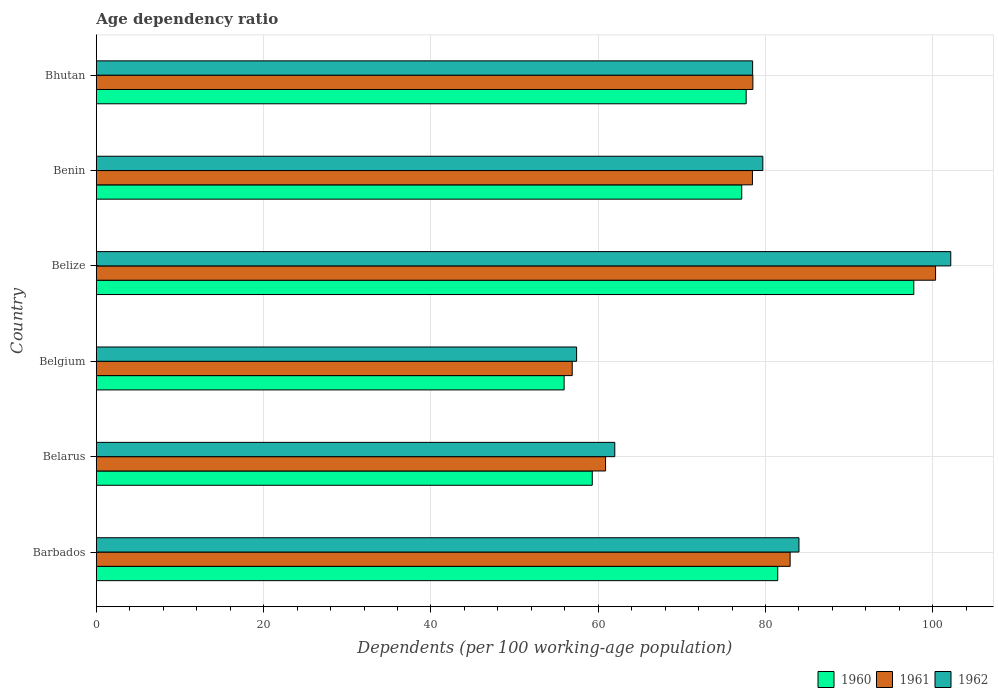How many groups of bars are there?
Your answer should be compact. 6. How many bars are there on the 5th tick from the bottom?
Give a very brief answer. 3. What is the label of the 2nd group of bars from the top?
Offer a very short reply. Benin. What is the age dependency ratio in in 1960 in Belgium?
Offer a terse response. 55.92. Across all countries, what is the maximum age dependency ratio in in 1960?
Give a very brief answer. 97.73. Across all countries, what is the minimum age dependency ratio in in 1962?
Provide a succinct answer. 57.42. In which country was the age dependency ratio in in 1961 maximum?
Your response must be concise. Belize. What is the total age dependency ratio in in 1961 in the graph?
Offer a very short reply. 457.97. What is the difference between the age dependency ratio in in 1960 in Barbados and that in Bhutan?
Ensure brevity in your answer.  3.77. What is the difference between the age dependency ratio in in 1962 in Benin and the age dependency ratio in in 1960 in Belgium?
Make the answer very short. 23.76. What is the average age dependency ratio in in 1961 per country?
Your answer should be compact. 76.33. What is the difference between the age dependency ratio in in 1962 and age dependency ratio in in 1960 in Barbados?
Provide a succinct answer. 2.54. What is the ratio of the age dependency ratio in in 1960 in Belarus to that in Belgium?
Offer a very short reply. 1.06. What is the difference between the highest and the second highest age dependency ratio in in 1960?
Offer a very short reply. 16.27. What is the difference between the highest and the lowest age dependency ratio in in 1962?
Your answer should be very brief. 44.73. Is the sum of the age dependency ratio in in 1962 in Barbados and Benin greater than the maximum age dependency ratio in in 1960 across all countries?
Make the answer very short. Yes. Is it the case that in every country, the sum of the age dependency ratio in in 1960 and age dependency ratio in in 1961 is greater than the age dependency ratio in in 1962?
Give a very brief answer. Yes. How many countries are there in the graph?
Keep it short and to the point. 6. What is the difference between two consecutive major ticks on the X-axis?
Your answer should be compact. 20. Are the values on the major ticks of X-axis written in scientific E-notation?
Give a very brief answer. No. What is the title of the graph?
Offer a very short reply. Age dependency ratio. What is the label or title of the X-axis?
Your answer should be very brief. Dependents (per 100 working-age population). What is the label or title of the Y-axis?
Give a very brief answer. Country. What is the Dependents (per 100 working-age population) of 1960 in Barbados?
Provide a succinct answer. 81.46. What is the Dependents (per 100 working-age population) of 1961 in Barbados?
Give a very brief answer. 82.94. What is the Dependents (per 100 working-age population) in 1962 in Barbados?
Offer a very short reply. 84. What is the Dependents (per 100 working-age population) in 1960 in Belarus?
Your answer should be compact. 59.29. What is the Dependents (per 100 working-age population) in 1961 in Belarus?
Provide a short and direct response. 60.88. What is the Dependents (per 100 working-age population) of 1962 in Belarus?
Make the answer very short. 61.98. What is the Dependents (per 100 working-age population) in 1960 in Belgium?
Your answer should be compact. 55.92. What is the Dependents (per 100 working-age population) in 1961 in Belgium?
Make the answer very short. 56.89. What is the Dependents (per 100 working-age population) in 1962 in Belgium?
Your response must be concise. 57.42. What is the Dependents (per 100 working-age population) in 1960 in Belize?
Ensure brevity in your answer.  97.73. What is the Dependents (per 100 working-age population) of 1961 in Belize?
Offer a terse response. 100.33. What is the Dependents (per 100 working-age population) in 1962 in Belize?
Keep it short and to the point. 102.15. What is the Dependents (per 100 working-age population) of 1960 in Benin?
Provide a short and direct response. 77.16. What is the Dependents (per 100 working-age population) of 1961 in Benin?
Offer a very short reply. 78.44. What is the Dependents (per 100 working-age population) in 1962 in Benin?
Offer a terse response. 79.68. What is the Dependents (per 100 working-age population) in 1960 in Bhutan?
Keep it short and to the point. 77.69. What is the Dependents (per 100 working-age population) in 1961 in Bhutan?
Offer a very short reply. 78.49. What is the Dependents (per 100 working-age population) in 1962 in Bhutan?
Your answer should be compact. 78.46. Across all countries, what is the maximum Dependents (per 100 working-age population) of 1960?
Offer a very short reply. 97.73. Across all countries, what is the maximum Dependents (per 100 working-age population) of 1961?
Ensure brevity in your answer.  100.33. Across all countries, what is the maximum Dependents (per 100 working-age population) in 1962?
Give a very brief answer. 102.15. Across all countries, what is the minimum Dependents (per 100 working-age population) in 1960?
Offer a terse response. 55.92. Across all countries, what is the minimum Dependents (per 100 working-age population) of 1961?
Offer a very short reply. 56.89. Across all countries, what is the minimum Dependents (per 100 working-age population) in 1962?
Offer a very short reply. 57.42. What is the total Dependents (per 100 working-age population) in 1960 in the graph?
Make the answer very short. 449.25. What is the total Dependents (per 100 working-age population) in 1961 in the graph?
Give a very brief answer. 457.97. What is the total Dependents (per 100 working-age population) of 1962 in the graph?
Your answer should be compact. 463.68. What is the difference between the Dependents (per 100 working-age population) in 1960 in Barbados and that in Belarus?
Offer a very short reply. 22.17. What is the difference between the Dependents (per 100 working-age population) in 1961 in Barbados and that in Belarus?
Keep it short and to the point. 22.06. What is the difference between the Dependents (per 100 working-age population) of 1962 in Barbados and that in Belarus?
Your answer should be compact. 22.02. What is the difference between the Dependents (per 100 working-age population) in 1960 in Barbados and that in Belgium?
Offer a terse response. 25.54. What is the difference between the Dependents (per 100 working-age population) of 1961 in Barbados and that in Belgium?
Offer a terse response. 26.05. What is the difference between the Dependents (per 100 working-age population) of 1962 in Barbados and that in Belgium?
Keep it short and to the point. 26.58. What is the difference between the Dependents (per 100 working-age population) of 1960 in Barbados and that in Belize?
Provide a succinct answer. -16.27. What is the difference between the Dependents (per 100 working-age population) in 1961 in Barbados and that in Belize?
Provide a succinct answer. -17.39. What is the difference between the Dependents (per 100 working-age population) in 1962 in Barbados and that in Belize?
Your answer should be compact. -18.15. What is the difference between the Dependents (per 100 working-age population) in 1960 in Barbados and that in Benin?
Offer a terse response. 4.3. What is the difference between the Dependents (per 100 working-age population) of 1961 in Barbados and that in Benin?
Provide a succinct answer. 4.51. What is the difference between the Dependents (per 100 working-age population) of 1962 in Barbados and that in Benin?
Your answer should be very brief. 4.32. What is the difference between the Dependents (per 100 working-age population) of 1960 in Barbados and that in Bhutan?
Provide a short and direct response. 3.77. What is the difference between the Dependents (per 100 working-age population) in 1961 in Barbados and that in Bhutan?
Provide a short and direct response. 4.45. What is the difference between the Dependents (per 100 working-age population) of 1962 in Barbados and that in Bhutan?
Keep it short and to the point. 5.54. What is the difference between the Dependents (per 100 working-age population) in 1960 in Belarus and that in Belgium?
Your answer should be very brief. 3.36. What is the difference between the Dependents (per 100 working-age population) in 1961 in Belarus and that in Belgium?
Keep it short and to the point. 3.99. What is the difference between the Dependents (per 100 working-age population) of 1962 in Belarus and that in Belgium?
Offer a very short reply. 4.56. What is the difference between the Dependents (per 100 working-age population) in 1960 in Belarus and that in Belize?
Offer a terse response. -38.44. What is the difference between the Dependents (per 100 working-age population) of 1961 in Belarus and that in Belize?
Your answer should be very brief. -39.45. What is the difference between the Dependents (per 100 working-age population) in 1962 in Belarus and that in Belize?
Offer a very short reply. -40.17. What is the difference between the Dependents (per 100 working-age population) of 1960 in Belarus and that in Benin?
Your answer should be compact. -17.87. What is the difference between the Dependents (per 100 working-age population) in 1961 in Belarus and that in Benin?
Give a very brief answer. -17.56. What is the difference between the Dependents (per 100 working-age population) in 1962 in Belarus and that in Benin?
Ensure brevity in your answer.  -17.7. What is the difference between the Dependents (per 100 working-age population) of 1960 in Belarus and that in Bhutan?
Make the answer very short. -18.4. What is the difference between the Dependents (per 100 working-age population) in 1961 in Belarus and that in Bhutan?
Provide a short and direct response. -17.61. What is the difference between the Dependents (per 100 working-age population) of 1962 in Belarus and that in Bhutan?
Provide a succinct answer. -16.48. What is the difference between the Dependents (per 100 working-age population) of 1960 in Belgium and that in Belize?
Your answer should be very brief. -41.8. What is the difference between the Dependents (per 100 working-age population) of 1961 in Belgium and that in Belize?
Ensure brevity in your answer.  -43.44. What is the difference between the Dependents (per 100 working-age population) of 1962 in Belgium and that in Belize?
Provide a short and direct response. -44.73. What is the difference between the Dependents (per 100 working-age population) in 1960 in Belgium and that in Benin?
Keep it short and to the point. -21.23. What is the difference between the Dependents (per 100 working-age population) in 1961 in Belgium and that in Benin?
Your answer should be very brief. -21.55. What is the difference between the Dependents (per 100 working-age population) of 1962 in Belgium and that in Benin?
Ensure brevity in your answer.  -22.26. What is the difference between the Dependents (per 100 working-age population) in 1960 in Belgium and that in Bhutan?
Your answer should be compact. -21.76. What is the difference between the Dependents (per 100 working-age population) in 1961 in Belgium and that in Bhutan?
Your response must be concise. -21.6. What is the difference between the Dependents (per 100 working-age population) of 1962 in Belgium and that in Bhutan?
Your answer should be compact. -21.04. What is the difference between the Dependents (per 100 working-age population) of 1960 in Belize and that in Benin?
Ensure brevity in your answer.  20.57. What is the difference between the Dependents (per 100 working-age population) of 1961 in Belize and that in Benin?
Provide a short and direct response. 21.89. What is the difference between the Dependents (per 100 working-age population) in 1962 in Belize and that in Benin?
Offer a very short reply. 22.47. What is the difference between the Dependents (per 100 working-age population) in 1960 in Belize and that in Bhutan?
Your answer should be compact. 20.04. What is the difference between the Dependents (per 100 working-age population) of 1961 in Belize and that in Bhutan?
Give a very brief answer. 21.84. What is the difference between the Dependents (per 100 working-age population) in 1962 in Belize and that in Bhutan?
Your answer should be compact. 23.69. What is the difference between the Dependents (per 100 working-age population) in 1960 in Benin and that in Bhutan?
Provide a short and direct response. -0.53. What is the difference between the Dependents (per 100 working-age population) of 1961 in Benin and that in Bhutan?
Provide a short and direct response. -0.05. What is the difference between the Dependents (per 100 working-age population) in 1962 in Benin and that in Bhutan?
Keep it short and to the point. 1.22. What is the difference between the Dependents (per 100 working-age population) in 1960 in Barbados and the Dependents (per 100 working-age population) in 1961 in Belarus?
Provide a short and direct response. 20.58. What is the difference between the Dependents (per 100 working-age population) in 1960 in Barbados and the Dependents (per 100 working-age population) in 1962 in Belarus?
Keep it short and to the point. 19.48. What is the difference between the Dependents (per 100 working-age population) in 1961 in Barbados and the Dependents (per 100 working-age population) in 1962 in Belarus?
Your answer should be very brief. 20.96. What is the difference between the Dependents (per 100 working-age population) in 1960 in Barbados and the Dependents (per 100 working-age population) in 1961 in Belgium?
Your answer should be compact. 24.57. What is the difference between the Dependents (per 100 working-age population) of 1960 in Barbados and the Dependents (per 100 working-age population) of 1962 in Belgium?
Provide a short and direct response. 24.04. What is the difference between the Dependents (per 100 working-age population) of 1961 in Barbados and the Dependents (per 100 working-age population) of 1962 in Belgium?
Your answer should be compact. 25.53. What is the difference between the Dependents (per 100 working-age population) in 1960 in Barbados and the Dependents (per 100 working-age population) in 1961 in Belize?
Your answer should be compact. -18.87. What is the difference between the Dependents (per 100 working-age population) of 1960 in Barbados and the Dependents (per 100 working-age population) of 1962 in Belize?
Offer a terse response. -20.69. What is the difference between the Dependents (per 100 working-age population) in 1961 in Barbados and the Dependents (per 100 working-age population) in 1962 in Belize?
Offer a terse response. -19.2. What is the difference between the Dependents (per 100 working-age population) in 1960 in Barbados and the Dependents (per 100 working-age population) in 1961 in Benin?
Ensure brevity in your answer.  3.02. What is the difference between the Dependents (per 100 working-age population) of 1960 in Barbados and the Dependents (per 100 working-age population) of 1962 in Benin?
Provide a succinct answer. 1.78. What is the difference between the Dependents (per 100 working-age population) of 1961 in Barbados and the Dependents (per 100 working-age population) of 1962 in Benin?
Provide a short and direct response. 3.26. What is the difference between the Dependents (per 100 working-age population) in 1960 in Barbados and the Dependents (per 100 working-age population) in 1961 in Bhutan?
Make the answer very short. 2.97. What is the difference between the Dependents (per 100 working-age population) in 1960 in Barbados and the Dependents (per 100 working-age population) in 1962 in Bhutan?
Give a very brief answer. 3. What is the difference between the Dependents (per 100 working-age population) of 1961 in Barbados and the Dependents (per 100 working-age population) of 1962 in Bhutan?
Your answer should be very brief. 4.48. What is the difference between the Dependents (per 100 working-age population) of 1960 in Belarus and the Dependents (per 100 working-age population) of 1961 in Belgium?
Your answer should be compact. 2.4. What is the difference between the Dependents (per 100 working-age population) of 1960 in Belarus and the Dependents (per 100 working-age population) of 1962 in Belgium?
Ensure brevity in your answer.  1.87. What is the difference between the Dependents (per 100 working-age population) of 1961 in Belarus and the Dependents (per 100 working-age population) of 1962 in Belgium?
Your answer should be very brief. 3.46. What is the difference between the Dependents (per 100 working-age population) of 1960 in Belarus and the Dependents (per 100 working-age population) of 1961 in Belize?
Give a very brief answer. -41.04. What is the difference between the Dependents (per 100 working-age population) in 1960 in Belarus and the Dependents (per 100 working-age population) in 1962 in Belize?
Provide a succinct answer. -42.86. What is the difference between the Dependents (per 100 working-age population) of 1961 in Belarus and the Dependents (per 100 working-age population) of 1962 in Belize?
Your answer should be compact. -41.27. What is the difference between the Dependents (per 100 working-age population) in 1960 in Belarus and the Dependents (per 100 working-age population) in 1961 in Benin?
Give a very brief answer. -19.15. What is the difference between the Dependents (per 100 working-age population) of 1960 in Belarus and the Dependents (per 100 working-age population) of 1962 in Benin?
Ensure brevity in your answer.  -20.39. What is the difference between the Dependents (per 100 working-age population) in 1961 in Belarus and the Dependents (per 100 working-age population) in 1962 in Benin?
Keep it short and to the point. -18.8. What is the difference between the Dependents (per 100 working-age population) in 1960 in Belarus and the Dependents (per 100 working-age population) in 1961 in Bhutan?
Your answer should be compact. -19.2. What is the difference between the Dependents (per 100 working-age population) of 1960 in Belarus and the Dependents (per 100 working-age population) of 1962 in Bhutan?
Keep it short and to the point. -19.17. What is the difference between the Dependents (per 100 working-age population) of 1961 in Belarus and the Dependents (per 100 working-age population) of 1962 in Bhutan?
Provide a succinct answer. -17.58. What is the difference between the Dependents (per 100 working-age population) of 1960 in Belgium and the Dependents (per 100 working-age population) of 1961 in Belize?
Offer a very short reply. -44.41. What is the difference between the Dependents (per 100 working-age population) in 1960 in Belgium and the Dependents (per 100 working-age population) in 1962 in Belize?
Your answer should be compact. -46.22. What is the difference between the Dependents (per 100 working-age population) of 1961 in Belgium and the Dependents (per 100 working-age population) of 1962 in Belize?
Your answer should be very brief. -45.26. What is the difference between the Dependents (per 100 working-age population) of 1960 in Belgium and the Dependents (per 100 working-age population) of 1961 in Benin?
Offer a terse response. -22.51. What is the difference between the Dependents (per 100 working-age population) in 1960 in Belgium and the Dependents (per 100 working-age population) in 1962 in Benin?
Ensure brevity in your answer.  -23.76. What is the difference between the Dependents (per 100 working-age population) of 1961 in Belgium and the Dependents (per 100 working-age population) of 1962 in Benin?
Your response must be concise. -22.79. What is the difference between the Dependents (per 100 working-age population) in 1960 in Belgium and the Dependents (per 100 working-age population) in 1961 in Bhutan?
Provide a short and direct response. -22.56. What is the difference between the Dependents (per 100 working-age population) in 1960 in Belgium and the Dependents (per 100 working-age population) in 1962 in Bhutan?
Your response must be concise. -22.54. What is the difference between the Dependents (per 100 working-age population) of 1961 in Belgium and the Dependents (per 100 working-age population) of 1962 in Bhutan?
Offer a very short reply. -21.57. What is the difference between the Dependents (per 100 working-age population) of 1960 in Belize and the Dependents (per 100 working-age population) of 1961 in Benin?
Offer a terse response. 19.29. What is the difference between the Dependents (per 100 working-age population) of 1960 in Belize and the Dependents (per 100 working-age population) of 1962 in Benin?
Give a very brief answer. 18.05. What is the difference between the Dependents (per 100 working-age population) in 1961 in Belize and the Dependents (per 100 working-age population) in 1962 in Benin?
Make the answer very short. 20.65. What is the difference between the Dependents (per 100 working-age population) in 1960 in Belize and the Dependents (per 100 working-age population) in 1961 in Bhutan?
Your response must be concise. 19.24. What is the difference between the Dependents (per 100 working-age population) of 1960 in Belize and the Dependents (per 100 working-age population) of 1962 in Bhutan?
Provide a succinct answer. 19.27. What is the difference between the Dependents (per 100 working-age population) of 1961 in Belize and the Dependents (per 100 working-age population) of 1962 in Bhutan?
Your answer should be very brief. 21.87. What is the difference between the Dependents (per 100 working-age population) in 1960 in Benin and the Dependents (per 100 working-age population) in 1961 in Bhutan?
Give a very brief answer. -1.33. What is the difference between the Dependents (per 100 working-age population) of 1960 in Benin and the Dependents (per 100 working-age population) of 1962 in Bhutan?
Ensure brevity in your answer.  -1.3. What is the difference between the Dependents (per 100 working-age population) of 1961 in Benin and the Dependents (per 100 working-age population) of 1962 in Bhutan?
Ensure brevity in your answer.  -0.02. What is the average Dependents (per 100 working-age population) in 1960 per country?
Give a very brief answer. 74.87. What is the average Dependents (per 100 working-age population) of 1961 per country?
Give a very brief answer. 76.33. What is the average Dependents (per 100 working-age population) of 1962 per country?
Keep it short and to the point. 77.28. What is the difference between the Dependents (per 100 working-age population) in 1960 and Dependents (per 100 working-age population) in 1961 in Barbados?
Provide a short and direct response. -1.48. What is the difference between the Dependents (per 100 working-age population) of 1960 and Dependents (per 100 working-age population) of 1962 in Barbados?
Your response must be concise. -2.54. What is the difference between the Dependents (per 100 working-age population) of 1961 and Dependents (per 100 working-age population) of 1962 in Barbados?
Keep it short and to the point. -1.06. What is the difference between the Dependents (per 100 working-age population) of 1960 and Dependents (per 100 working-age population) of 1961 in Belarus?
Offer a very short reply. -1.59. What is the difference between the Dependents (per 100 working-age population) in 1960 and Dependents (per 100 working-age population) in 1962 in Belarus?
Ensure brevity in your answer.  -2.69. What is the difference between the Dependents (per 100 working-age population) in 1961 and Dependents (per 100 working-age population) in 1962 in Belarus?
Give a very brief answer. -1.1. What is the difference between the Dependents (per 100 working-age population) in 1960 and Dependents (per 100 working-age population) in 1961 in Belgium?
Your answer should be very brief. -0.97. What is the difference between the Dependents (per 100 working-age population) in 1960 and Dependents (per 100 working-age population) in 1962 in Belgium?
Provide a succinct answer. -1.49. What is the difference between the Dependents (per 100 working-age population) in 1961 and Dependents (per 100 working-age population) in 1962 in Belgium?
Make the answer very short. -0.53. What is the difference between the Dependents (per 100 working-age population) in 1960 and Dependents (per 100 working-age population) in 1961 in Belize?
Ensure brevity in your answer.  -2.6. What is the difference between the Dependents (per 100 working-age population) in 1960 and Dependents (per 100 working-age population) in 1962 in Belize?
Your answer should be very brief. -4.42. What is the difference between the Dependents (per 100 working-age population) of 1961 and Dependents (per 100 working-age population) of 1962 in Belize?
Provide a short and direct response. -1.82. What is the difference between the Dependents (per 100 working-age population) of 1960 and Dependents (per 100 working-age population) of 1961 in Benin?
Your response must be concise. -1.28. What is the difference between the Dependents (per 100 working-age population) of 1960 and Dependents (per 100 working-age population) of 1962 in Benin?
Offer a very short reply. -2.52. What is the difference between the Dependents (per 100 working-age population) in 1961 and Dependents (per 100 working-age population) in 1962 in Benin?
Ensure brevity in your answer.  -1.24. What is the difference between the Dependents (per 100 working-age population) in 1960 and Dependents (per 100 working-age population) in 1961 in Bhutan?
Your response must be concise. -0.8. What is the difference between the Dependents (per 100 working-age population) in 1960 and Dependents (per 100 working-age population) in 1962 in Bhutan?
Offer a terse response. -0.77. What is the difference between the Dependents (per 100 working-age population) in 1961 and Dependents (per 100 working-age population) in 1962 in Bhutan?
Your response must be concise. 0.03. What is the ratio of the Dependents (per 100 working-age population) of 1960 in Barbados to that in Belarus?
Provide a succinct answer. 1.37. What is the ratio of the Dependents (per 100 working-age population) of 1961 in Barbados to that in Belarus?
Provide a short and direct response. 1.36. What is the ratio of the Dependents (per 100 working-age population) of 1962 in Barbados to that in Belarus?
Ensure brevity in your answer.  1.36. What is the ratio of the Dependents (per 100 working-age population) of 1960 in Barbados to that in Belgium?
Your answer should be very brief. 1.46. What is the ratio of the Dependents (per 100 working-age population) in 1961 in Barbados to that in Belgium?
Provide a short and direct response. 1.46. What is the ratio of the Dependents (per 100 working-age population) of 1962 in Barbados to that in Belgium?
Offer a very short reply. 1.46. What is the ratio of the Dependents (per 100 working-age population) of 1960 in Barbados to that in Belize?
Make the answer very short. 0.83. What is the ratio of the Dependents (per 100 working-age population) in 1961 in Barbados to that in Belize?
Your answer should be very brief. 0.83. What is the ratio of the Dependents (per 100 working-age population) of 1962 in Barbados to that in Belize?
Offer a terse response. 0.82. What is the ratio of the Dependents (per 100 working-age population) of 1960 in Barbados to that in Benin?
Your response must be concise. 1.06. What is the ratio of the Dependents (per 100 working-age population) of 1961 in Barbados to that in Benin?
Keep it short and to the point. 1.06. What is the ratio of the Dependents (per 100 working-age population) in 1962 in Barbados to that in Benin?
Give a very brief answer. 1.05. What is the ratio of the Dependents (per 100 working-age population) of 1960 in Barbados to that in Bhutan?
Provide a succinct answer. 1.05. What is the ratio of the Dependents (per 100 working-age population) in 1961 in Barbados to that in Bhutan?
Give a very brief answer. 1.06. What is the ratio of the Dependents (per 100 working-age population) in 1962 in Barbados to that in Bhutan?
Your response must be concise. 1.07. What is the ratio of the Dependents (per 100 working-age population) of 1960 in Belarus to that in Belgium?
Offer a very short reply. 1.06. What is the ratio of the Dependents (per 100 working-age population) of 1961 in Belarus to that in Belgium?
Make the answer very short. 1.07. What is the ratio of the Dependents (per 100 working-age population) in 1962 in Belarus to that in Belgium?
Your response must be concise. 1.08. What is the ratio of the Dependents (per 100 working-age population) of 1960 in Belarus to that in Belize?
Provide a succinct answer. 0.61. What is the ratio of the Dependents (per 100 working-age population) of 1961 in Belarus to that in Belize?
Offer a very short reply. 0.61. What is the ratio of the Dependents (per 100 working-age population) of 1962 in Belarus to that in Belize?
Make the answer very short. 0.61. What is the ratio of the Dependents (per 100 working-age population) in 1960 in Belarus to that in Benin?
Offer a terse response. 0.77. What is the ratio of the Dependents (per 100 working-age population) in 1961 in Belarus to that in Benin?
Offer a terse response. 0.78. What is the ratio of the Dependents (per 100 working-age population) in 1962 in Belarus to that in Benin?
Make the answer very short. 0.78. What is the ratio of the Dependents (per 100 working-age population) in 1960 in Belarus to that in Bhutan?
Keep it short and to the point. 0.76. What is the ratio of the Dependents (per 100 working-age population) in 1961 in Belarus to that in Bhutan?
Make the answer very short. 0.78. What is the ratio of the Dependents (per 100 working-age population) in 1962 in Belarus to that in Bhutan?
Ensure brevity in your answer.  0.79. What is the ratio of the Dependents (per 100 working-age population) of 1960 in Belgium to that in Belize?
Your answer should be very brief. 0.57. What is the ratio of the Dependents (per 100 working-age population) of 1961 in Belgium to that in Belize?
Give a very brief answer. 0.57. What is the ratio of the Dependents (per 100 working-age population) in 1962 in Belgium to that in Belize?
Your response must be concise. 0.56. What is the ratio of the Dependents (per 100 working-age population) of 1960 in Belgium to that in Benin?
Offer a very short reply. 0.72. What is the ratio of the Dependents (per 100 working-age population) in 1961 in Belgium to that in Benin?
Offer a very short reply. 0.73. What is the ratio of the Dependents (per 100 working-age population) of 1962 in Belgium to that in Benin?
Offer a very short reply. 0.72. What is the ratio of the Dependents (per 100 working-age population) of 1960 in Belgium to that in Bhutan?
Give a very brief answer. 0.72. What is the ratio of the Dependents (per 100 working-age population) of 1961 in Belgium to that in Bhutan?
Your answer should be compact. 0.72. What is the ratio of the Dependents (per 100 working-age population) in 1962 in Belgium to that in Bhutan?
Offer a terse response. 0.73. What is the ratio of the Dependents (per 100 working-age population) in 1960 in Belize to that in Benin?
Give a very brief answer. 1.27. What is the ratio of the Dependents (per 100 working-age population) in 1961 in Belize to that in Benin?
Give a very brief answer. 1.28. What is the ratio of the Dependents (per 100 working-age population) in 1962 in Belize to that in Benin?
Your response must be concise. 1.28. What is the ratio of the Dependents (per 100 working-age population) of 1960 in Belize to that in Bhutan?
Ensure brevity in your answer.  1.26. What is the ratio of the Dependents (per 100 working-age population) of 1961 in Belize to that in Bhutan?
Give a very brief answer. 1.28. What is the ratio of the Dependents (per 100 working-age population) of 1962 in Belize to that in Bhutan?
Ensure brevity in your answer.  1.3. What is the ratio of the Dependents (per 100 working-age population) in 1961 in Benin to that in Bhutan?
Ensure brevity in your answer.  1. What is the ratio of the Dependents (per 100 working-age population) of 1962 in Benin to that in Bhutan?
Provide a succinct answer. 1.02. What is the difference between the highest and the second highest Dependents (per 100 working-age population) in 1960?
Your answer should be compact. 16.27. What is the difference between the highest and the second highest Dependents (per 100 working-age population) in 1961?
Make the answer very short. 17.39. What is the difference between the highest and the second highest Dependents (per 100 working-age population) in 1962?
Keep it short and to the point. 18.15. What is the difference between the highest and the lowest Dependents (per 100 working-age population) of 1960?
Ensure brevity in your answer.  41.8. What is the difference between the highest and the lowest Dependents (per 100 working-age population) in 1961?
Provide a succinct answer. 43.44. What is the difference between the highest and the lowest Dependents (per 100 working-age population) in 1962?
Your answer should be compact. 44.73. 